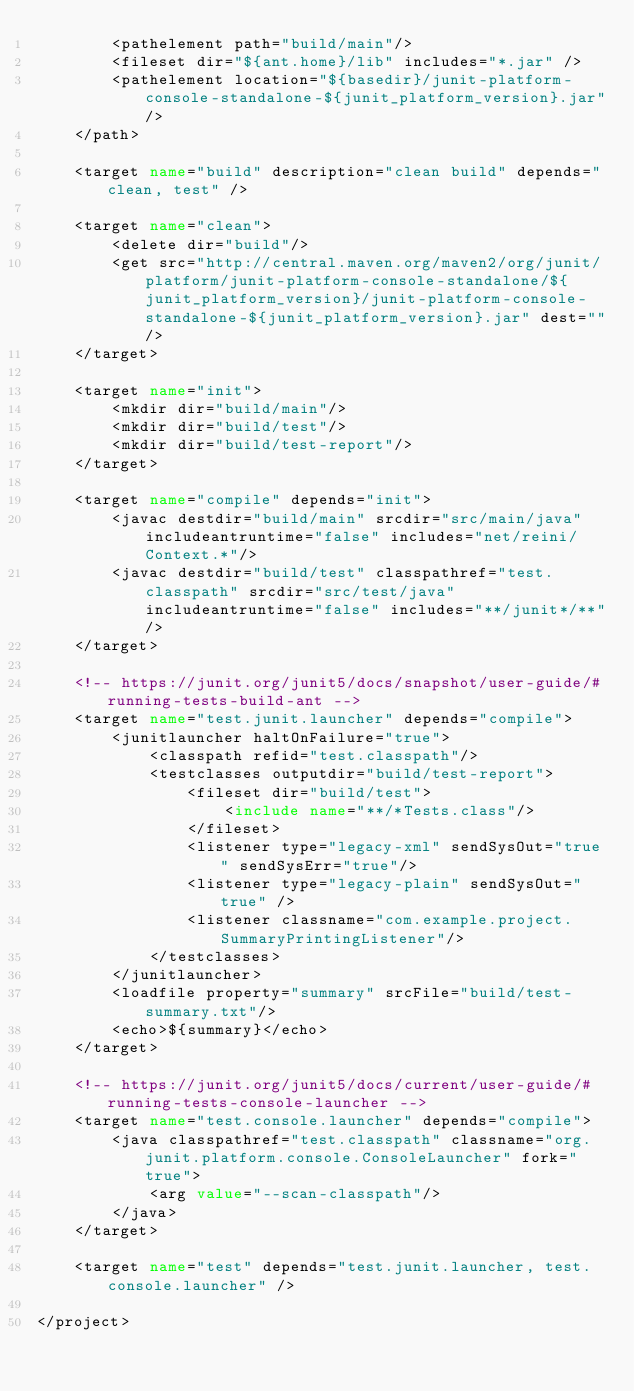<code> <loc_0><loc_0><loc_500><loc_500><_XML_>        <pathelement path="build/main"/>
        <fileset dir="${ant.home}/lib" includes="*.jar" />
        <pathelement location="${basedir}/junit-platform-console-standalone-${junit_platform_version}.jar"/>
    </path>

    <target name="build" description="clean build" depends="clean, test" />

    <target name="clean">
        <delete dir="build"/>
        <get src="http://central.maven.org/maven2/org/junit/platform/junit-platform-console-standalone/${junit_platform_version}/junit-platform-console-standalone-${junit_platform_version}.jar" dest=""/>
    </target>

    <target name="init">
        <mkdir dir="build/main"/>
        <mkdir dir="build/test"/>
        <mkdir dir="build/test-report"/>
    </target>

    <target name="compile" depends="init">
        <javac destdir="build/main" srcdir="src/main/java" includeantruntime="false" includes="net/reini/Context.*"/>
        <javac destdir="build/test" classpathref="test.classpath" srcdir="src/test/java" includeantruntime="false" includes="**/junit*/**"/>
    </target>

    <!-- https://junit.org/junit5/docs/snapshot/user-guide/#running-tests-build-ant -->
    <target name="test.junit.launcher" depends="compile">
        <junitlauncher haltOnFailure="true">
            <classpath refid="test.classpath"/>
            <testclasses outputdir="build/test-report">
                <fileset dir="build/test">
                    <include name="**/*Tests.class"/>
                </fileset>
                <listener type="legacy-xml" sendSysOut="true" sendSysErr="true"/>
                <listener type="legacy-plain" sendSysOut="true" />
                <listener classname="com.example.project.SummaryPrintingListener"/>
            </testclasses>
        </junitlauncher>
        <loadfile property="summary" srcFile="build/test-summary.txt"/>
        <echo>${summary}</echo>
    </target>

    <!-- https://junit.org/junit5/docs/current/user-guide/#running-tests-console-launcher -->
    <target name="test.console.launcher" depends="compile">
        <java classpathref="test.classpath" classname="org.junit.platform.console.ConsoleLauncher" fork="true">
            <arg value="--scan-classpath"/>
        </java>
    </target>

    <target name="test" depends="test.junit.launcher, test.console.launcher" />

</project>
</code> 